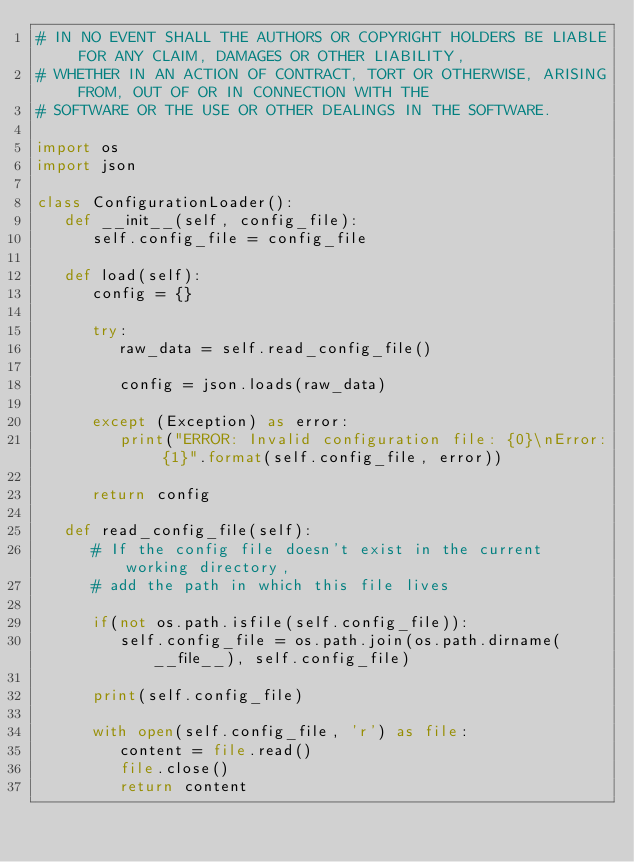Convert code to text. <code><loc_0><loc_0><loc_500><loc_500><_Python_># IN NO EVENT SHALL THE AUTHORS OR COPYRIGHT HOLDERS BE LIABLE FOR ANY CLAIM, DAMAGES OR OTHER LIABILITY,
# WHETHER IN AN ACTION OF CONTRACT, TORT OR OTHERWISE, ARISING FROM, OUT OF OR IN CONNECTION WITH THE 
# SOFTWARE OR THE USE OR OTHER DEALINGS IN THE SOFTWARE.

import os
import json

class ConfigurationLoader():
   def __init__(self, config_file):
      self.config_file = config_file

   def load(self):
      config = {}

      try:
         raw_data = self.read_config_file()

         config = json.loads(raw_data)

      except (Exception) as error:
         print("ERROR: Invalid configuration file: {0}\nError: {1}".format(self.config_file, error))         

      return config

   def read_config_file(self):
      # If the config file doesn't exist in the current working directory, 
      # add the path in which this file lives

      if(not os.path.isfile(self.config_file)):
         self.config_file = os.path.join(os.path.dirname(__file__), self.config_file)

      print(self.config_file)

      with open(self.config_file, 'r') as file:
         content = file.read()
         file.close()
         return content
</code> 